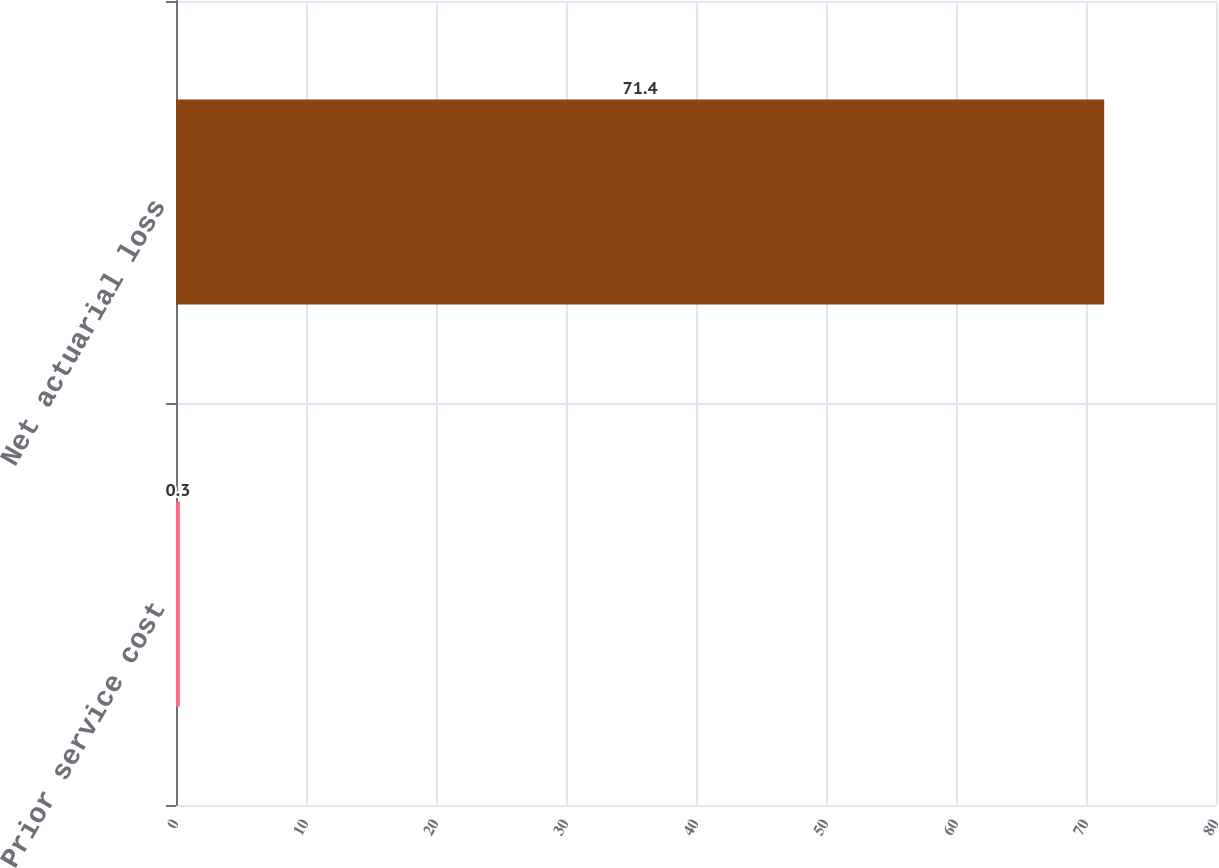Convert chart to OTSL. <chart><loc_0><loc_0><loc_500><loc_500><bar_chart><fcel>Prior service cost<fcel>Net actuarial loss<nl><fcel>0.3<fcel>71.4<nl></chart> 